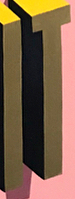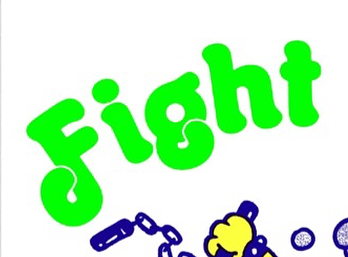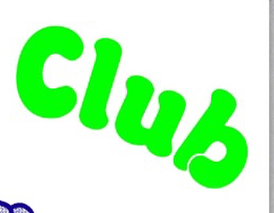What text is displayed in these images sequentially, separated by a semicolon? IT; Fight; Club 